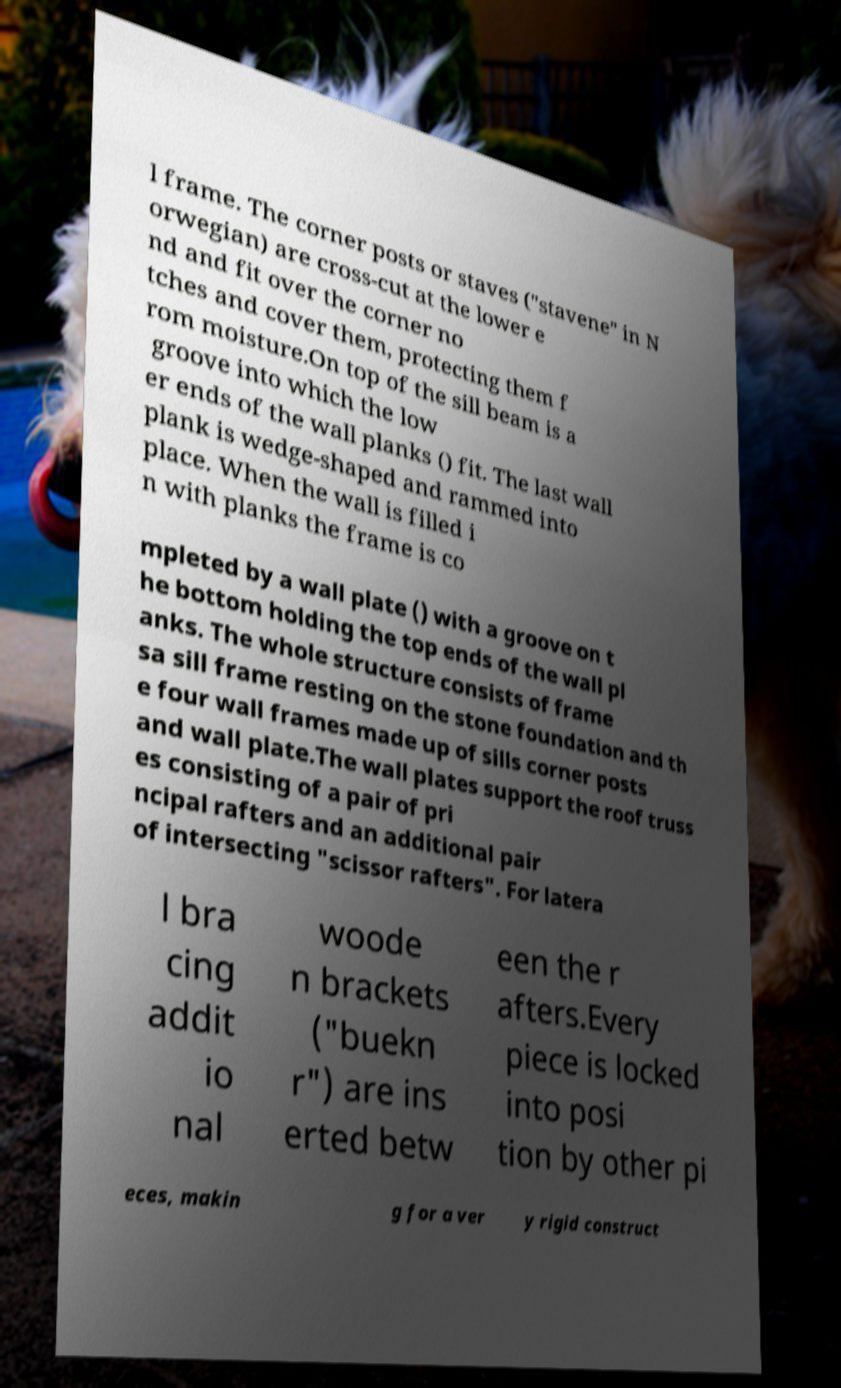What messages or text are displayed in this image? I need them in a readable, typed format. l frame. The corner posts or staves ("stavene" in N orwegian) are cross-cut at the lower e nd and fit over the corner no tches and cover them, protecting them f rom moisture.On top of the sill beam is a groove into which the low er ends of the wall planks () fit. The last wall plank is wedge-shaped and rammed into place. When the wall is filled i n with planks the frame is co mpleted by a wall plate () with a groove on t he bottom holding the top ends of the wall pl anks. The whole structure consists of frame sa sill frame resting on the stone foundation and th e four wall frames made up of sills corner posts and wall plate.The wall plates support the roof truss es consisting of a pair of pri ncipal rafters and an additional pair of intersecting "scissor rafters". For latera l bra cing addit io nal woode n brackets ("buekn r") are ins erted betw een the r afters.Every piece is locked into posi tion by other pi eces, makin g for a ver y rigid construct 